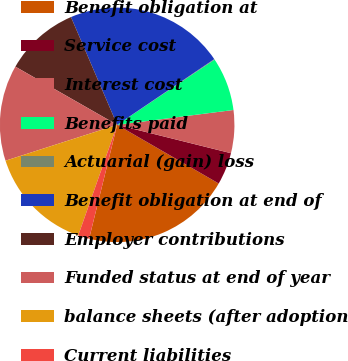Convert chart to OTSL. <chart><loc_0><loc_0><loc_500><loc_500><pie_chart><fcel>Benefit obligation at<fcel>Service cost<fcel>Interest cost<fcel>Benefits paid<fcel>Actuarial (gain) loss<fcel>Benefit obligation at end of<fcel>Employer contributions<fcel>Funded status at end of year<fcel>balance sheets (after adoption<fcel>Current liabilities<nl><fcel>20.51%<fcel>4.45%<fcel>5.91%<fcel>7.37%<fcel>0.08%<fcel>21.97%<fcel>10.29%<fcel>13.21%<fcel>14.67%<fcel>1.54%<nl></chart> 